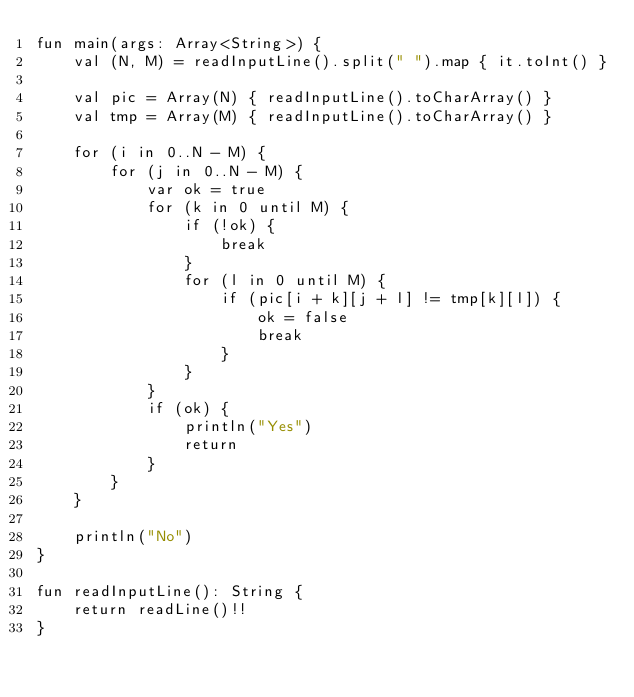Convert code to text. <code><loc_0><loc_0><loc_500><loc_500><_Kotlin_>fun main(args: Array<String>) {
    val (N, M) = readInputLine().split(" ").map { it.toInt() }
    
    val pic = Array(N) { readInputLine().toCharArray() }
    val tmp = Array(M) { readInputLine().toCharArray() }
    
    for (i in 0..N - M) {
        for (j in 0..N - M) {
            var ok = true
            for (k in 0 until M) {
                if (!ok) {
                    break
                }
                for (l in 0 until M) {
                    if (pic[i + k][j + l] != tmp[k][l]) {
                        ok = false
                        break
                    }
                }
            }
            if (ok) {
                println("Yes")
                return
            }
        }
    }
    
    println("No")
}

fun readInputLine(): String {
    return readLine()!!
}
</code> 